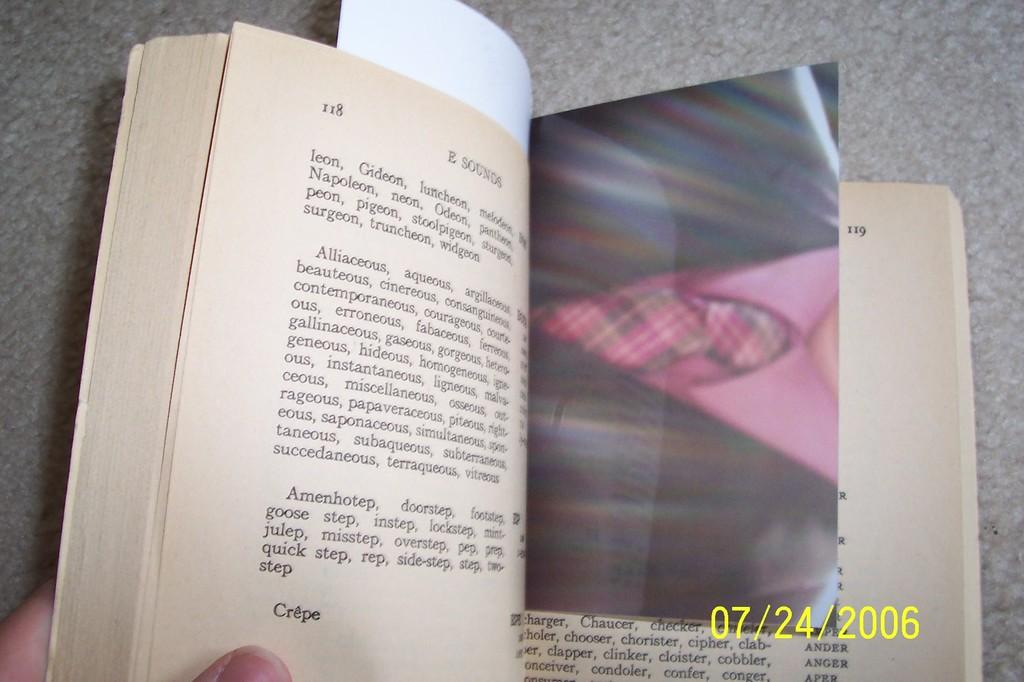Provide a one-sentence caption for the provided image. A picture from July of 2006 is being used as a book marker for someone. 